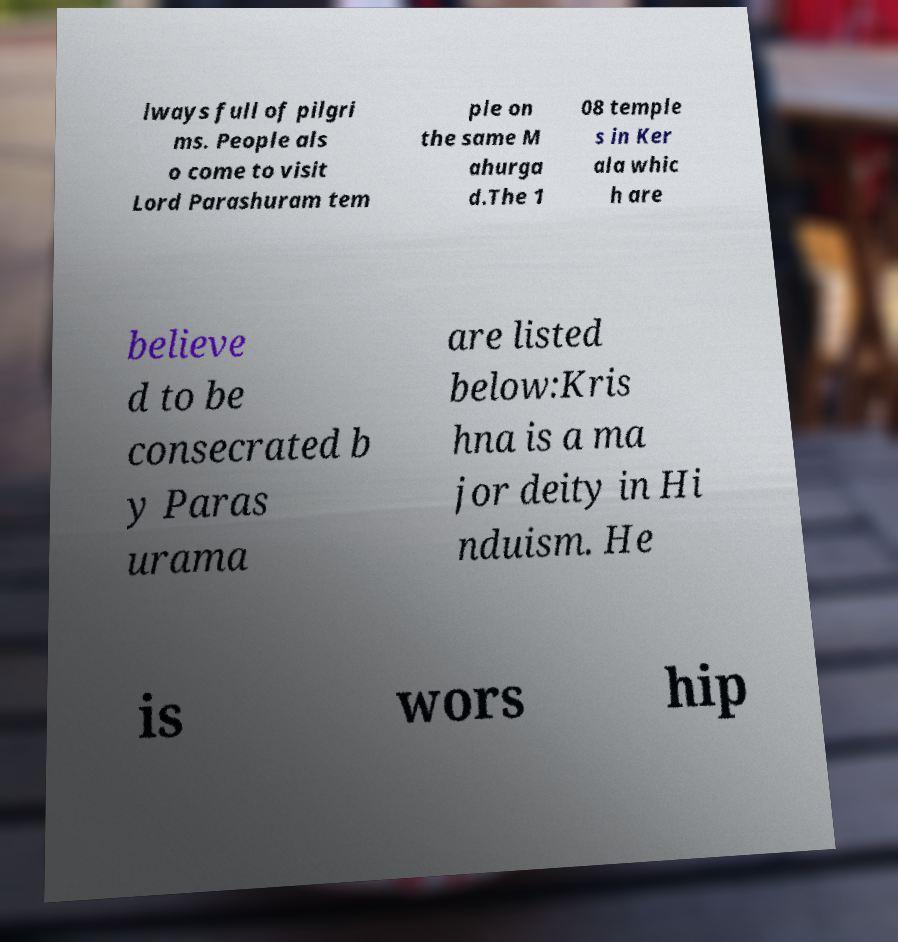What messages or text are displayed in this image? I need them in a readable, typed format. lways full of pilgri ms. People als o come to visit Lord Parashuram tem ple on the same M ahurga d.The 1 08 temple s in Ker ala whic h are believe d to be consecrated b y Paras urama are listed below:Kris hna is a ma jor deity in Hi nduism. He is wors hip 